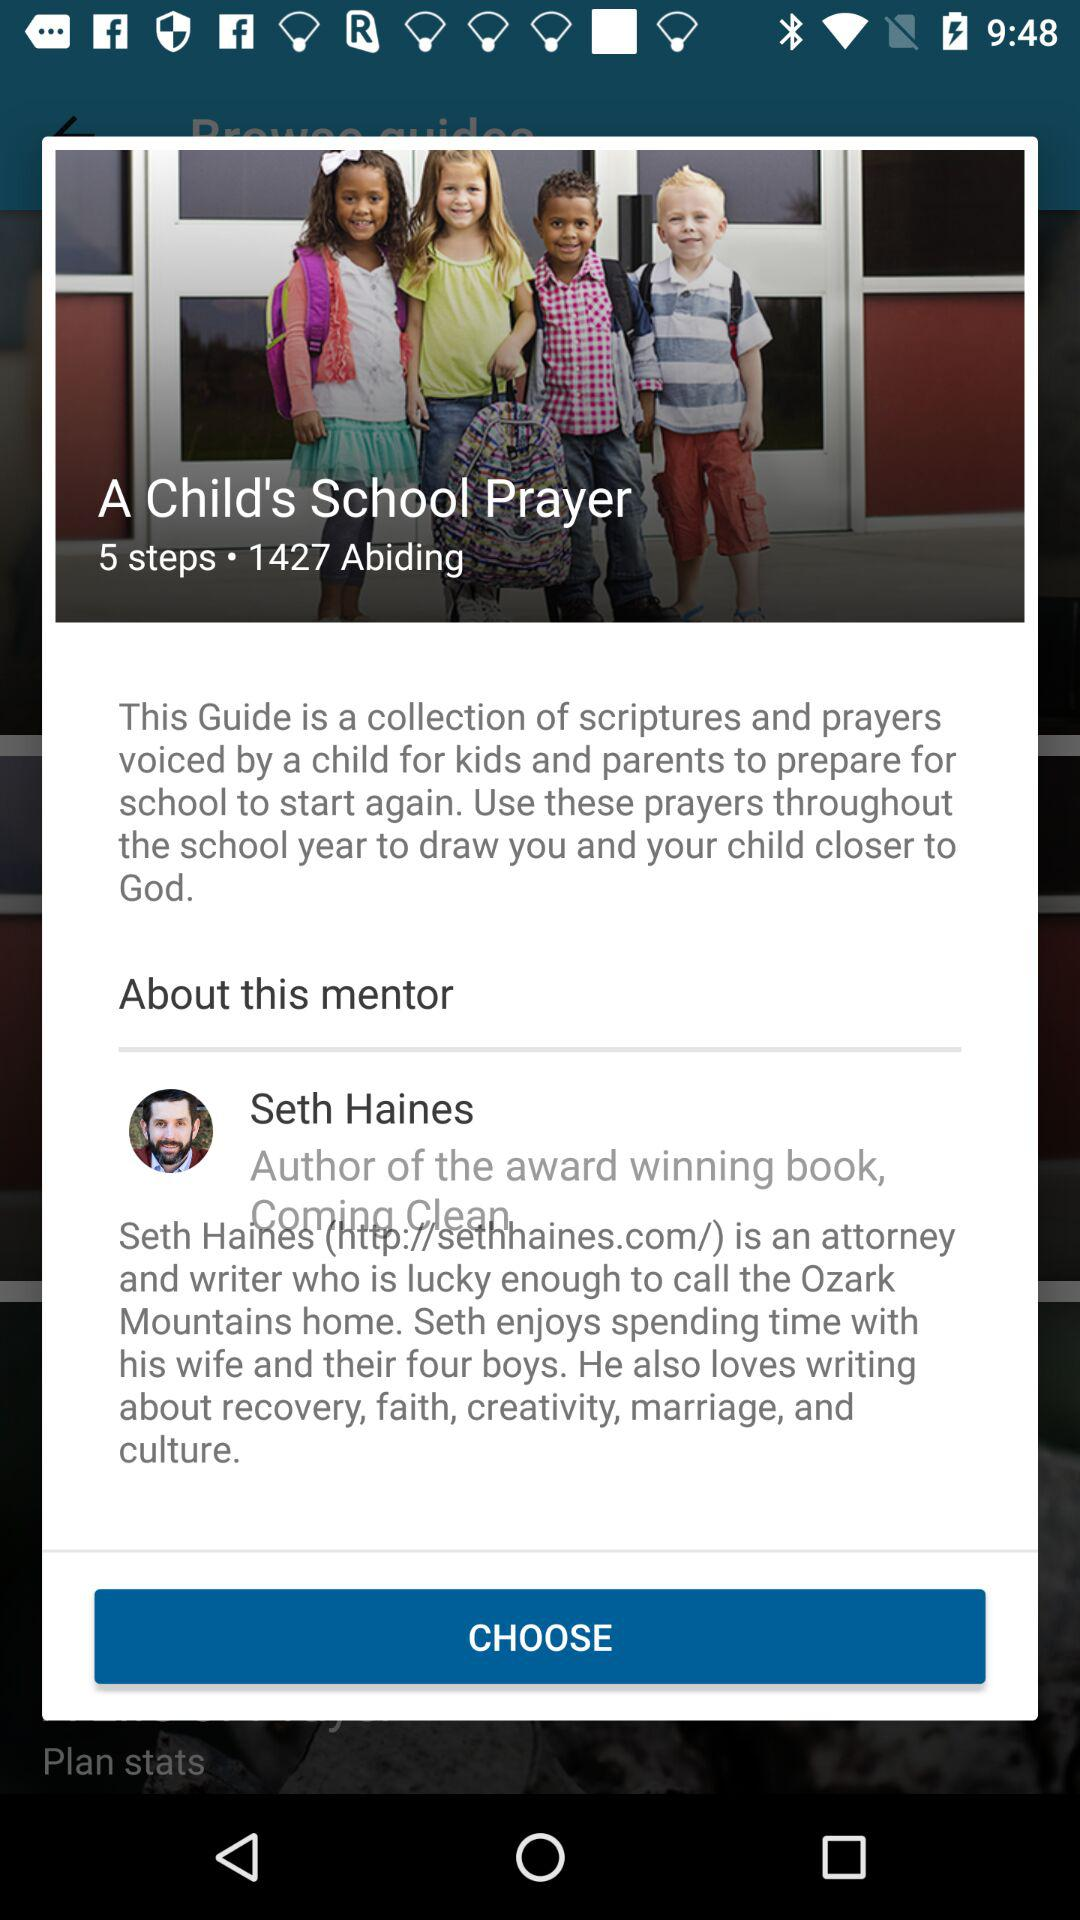What is the name of the author of the reading plan "A Child's School Prayer"? The name of the author is Seth Haines. 